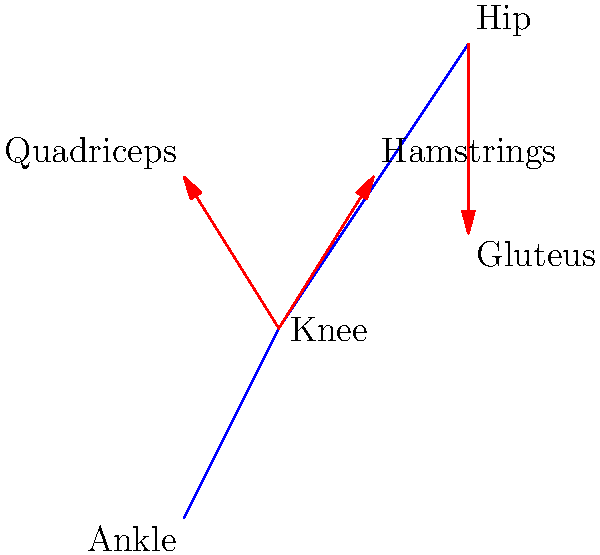In the given vector graphic representation of muscle forces during a squat exercise, which muscle group is primarily responsible for extending the knee joint and counteracting the external flexion moment? To answer this question, let's analyze the muscle forces depicted in the vector graphic:

1. The graphic shows a simplified representation of the lower body during a squat exercise.
2. Three main muscle groups are illustrated with force vectors:
   a. A vector pointing upward and slightly forward from the knee
   b. A vector pointing upward and slightly backward from the knee
   c. A vector pointing downward from the hip

3. Identifying the muscle groups:
   a. The vector pointing upward and slightly forward from the knee represents the quadriceps muscle group.
   b. The vector pointing upward and slightly backward from the knee represents the hamstrings muscle group.
   c. The vector pointing downward from the hip represents the gluteus muscle group.

4. Analyzing the function of each muscle group:
   a. Quadriceps: Extend the knee joint
   b. Hamstrings: Flex the knee joint and extend the hip
   c. Gluteus: Extend the hip joint

5. During a squat, the external load (body weight plus any additional weight) creates a flexion moment at the knee joint.

6. To counteract this flexion moment and extend the knee to rise from the squat position, the quadriceps muscle group must generate a large force.

Therefore, the muscle group primarily responsible for extending the knee joint and counteracting the external flexion moment during a squat is the quadriceps.
Answer: Quadriceps 